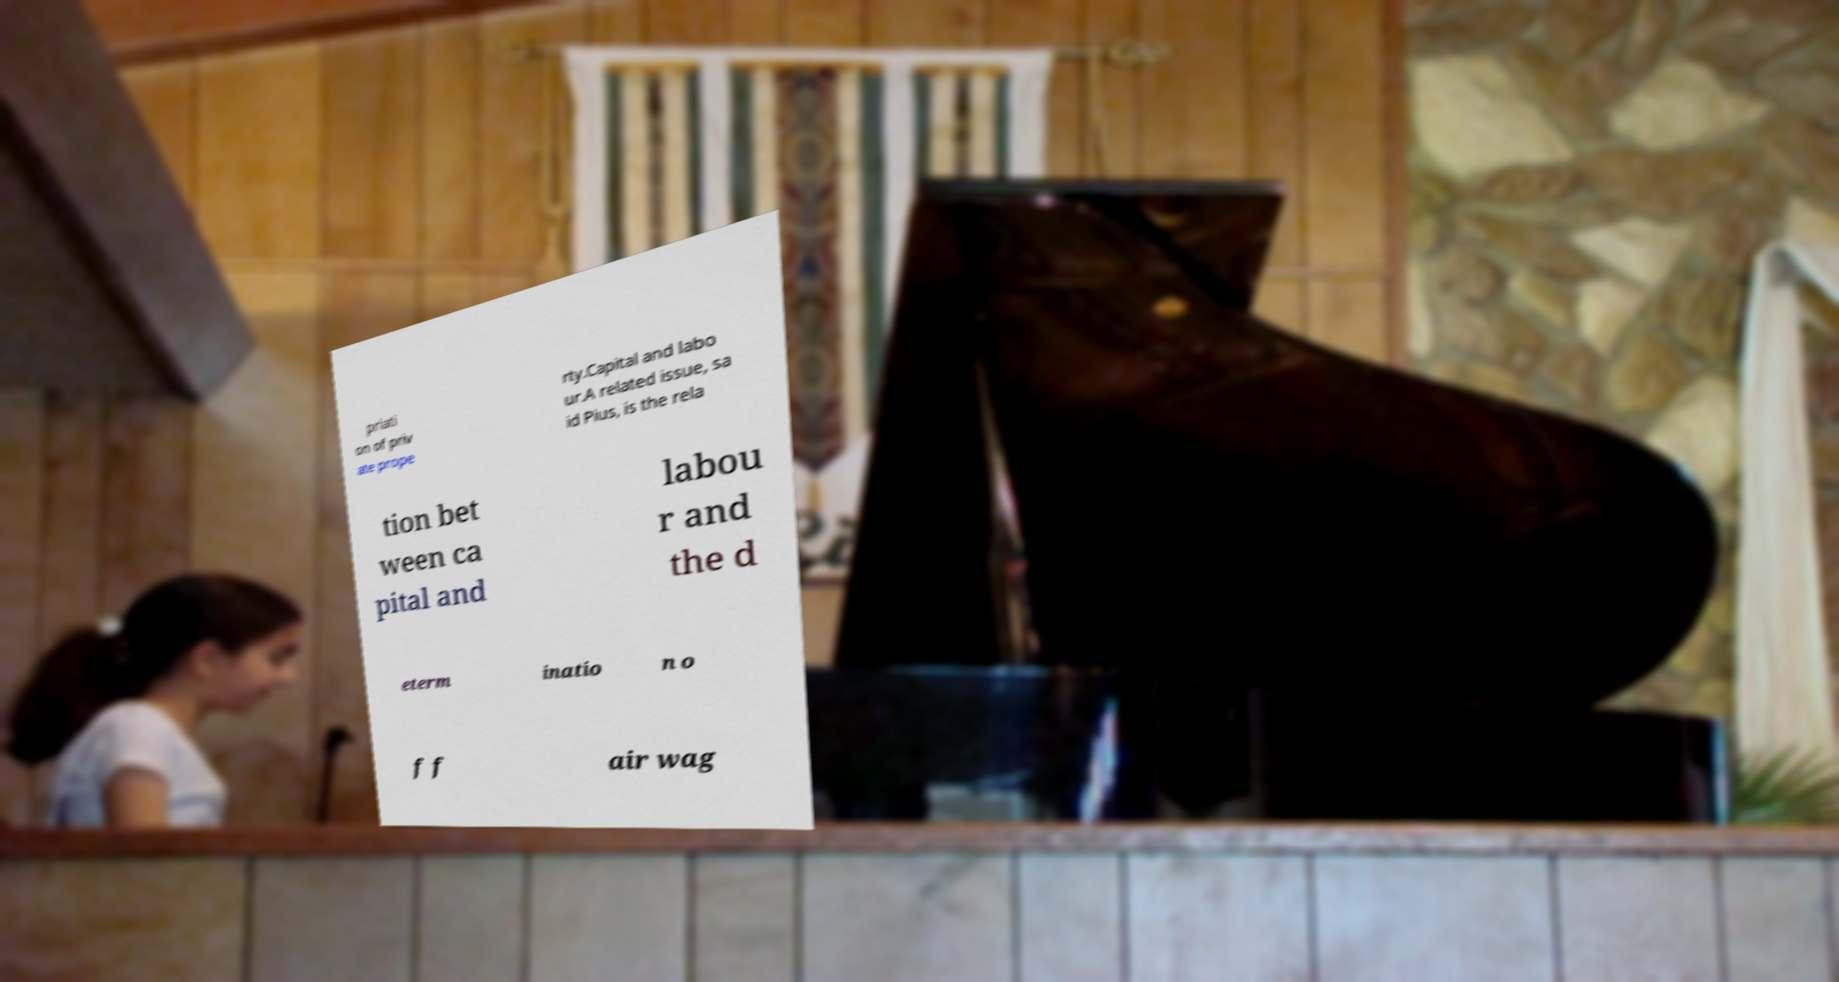Could you extract and type out the text from this image? priati on of priv ate prope rty.Capital and labo ur.A related issue, sa id Pius, is the rela tion bet ween ca pital and labou r and the d eterm inatio n o f f air wag 